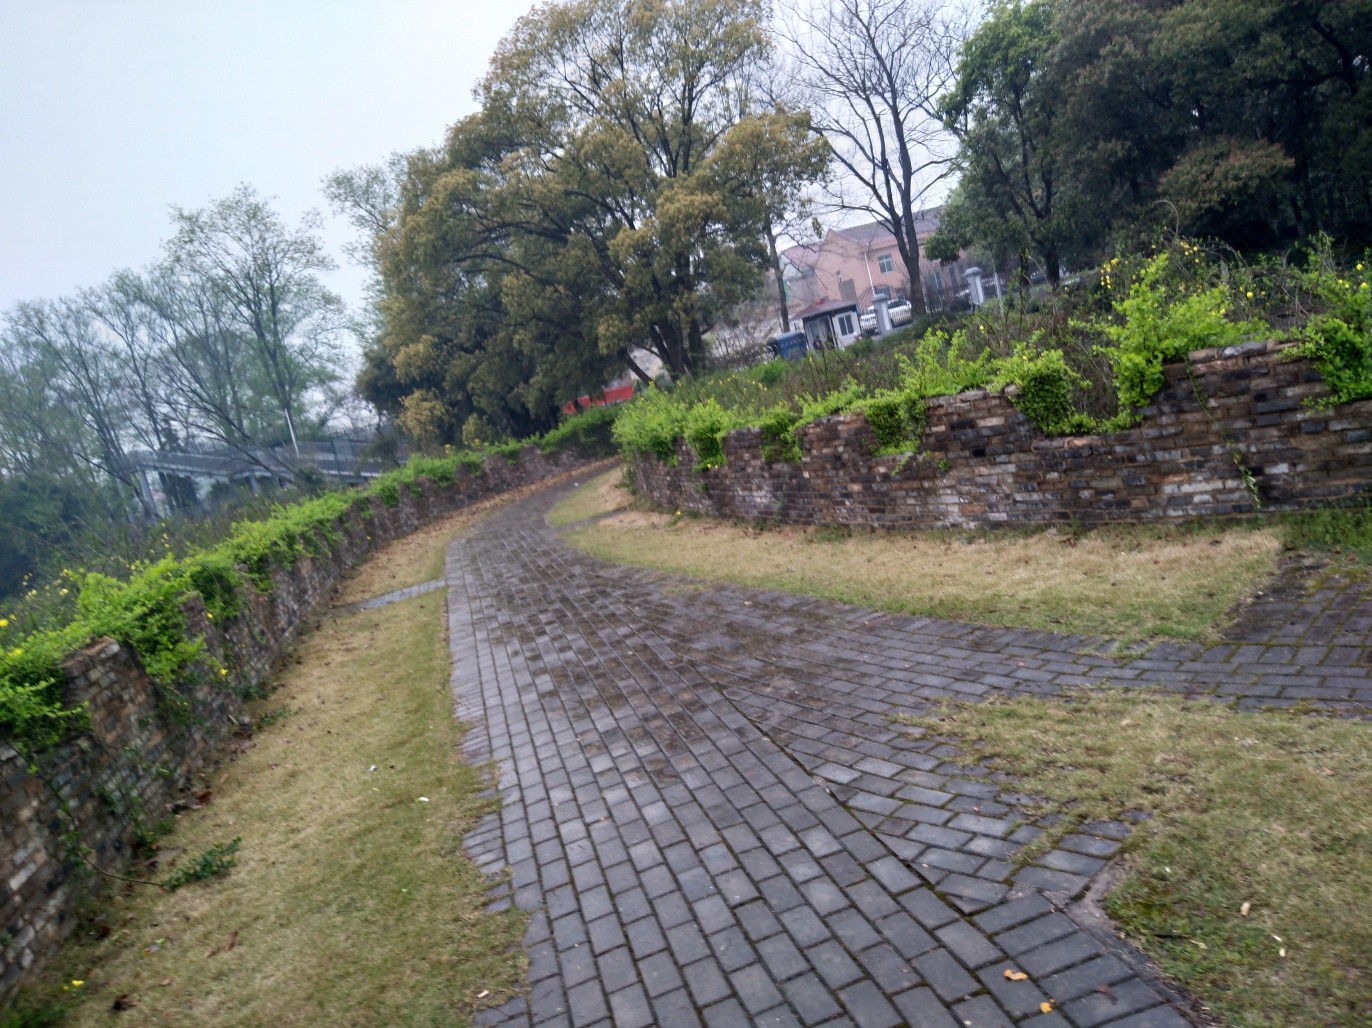What might be the historical significance of this location? The cobblestone pathway and the old stone wall bordering it suggest that this might be a path with some history. It could be located in an area with historical buildings or parks, retaining its original design as a tribute to the past. Its well-maintained condition indicates it might still be in active use, possibly located in a historic district or as part of a heritage conservation site. 